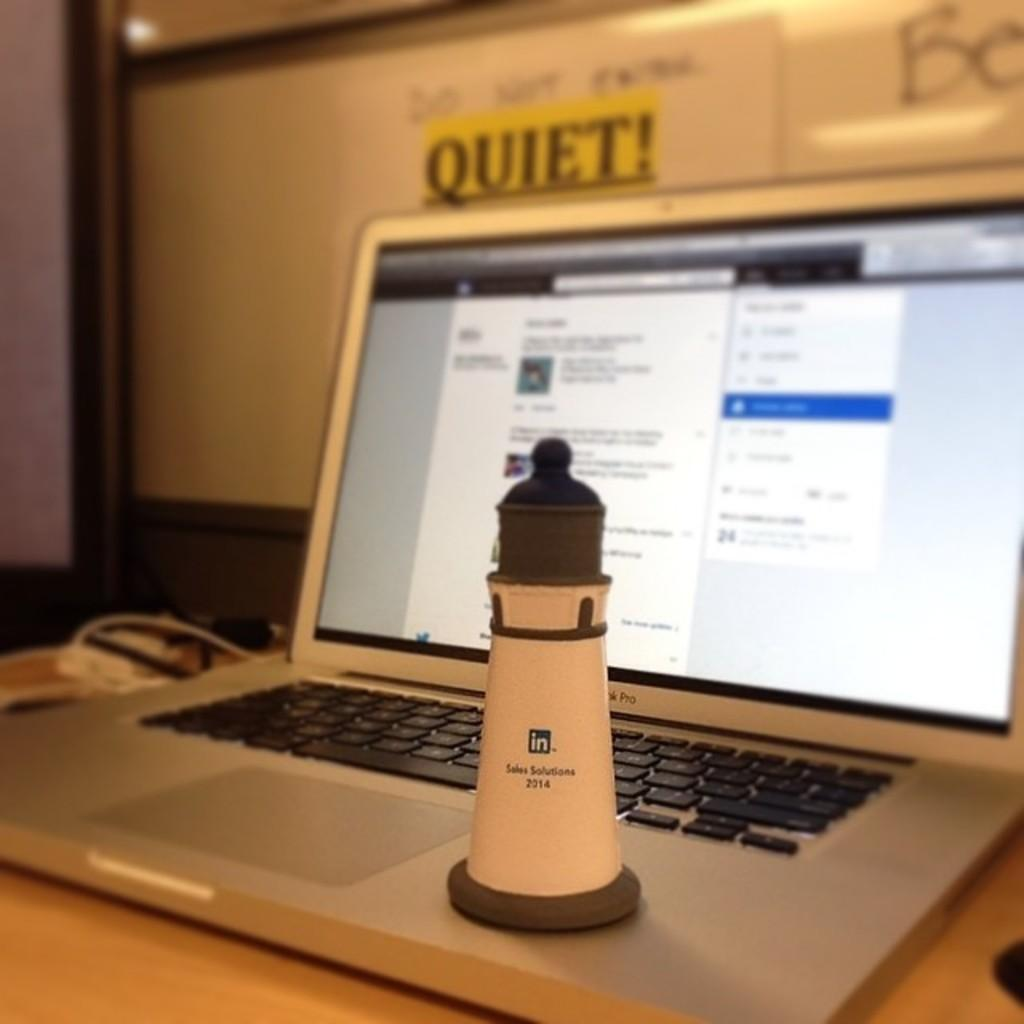Provide a one-sentence caption for the provided image. The sign above the laptop is warning everyone to be QUIET. 